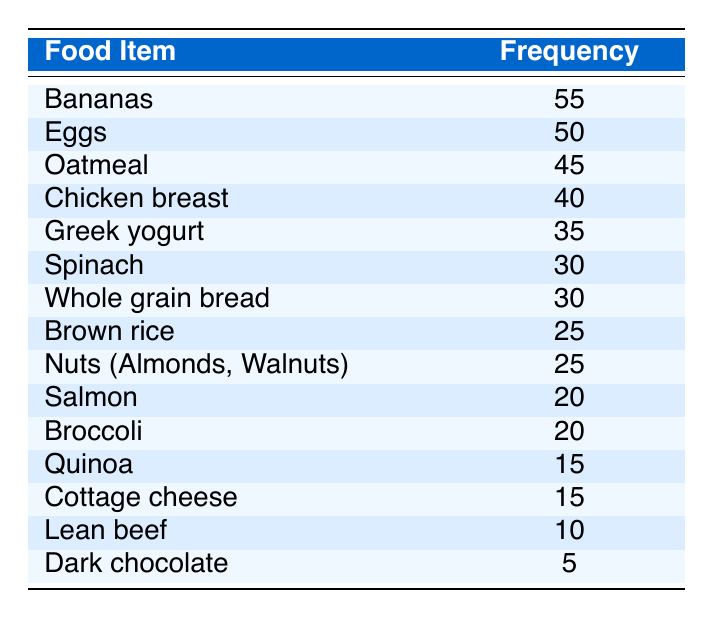What is the most frequently consumed food item among the gymnasts? The food item listed first in the table is "Bananas," with its frequency denoted as 55. This means that bananas are the most frequently consumed food item among the gymnasts.
Answer: Bananas How many food items are consumed more frequently than salmon? In the table, salmon has a frequency of 20. By checking each food item, we find that there are eight items with higher frequencies: bananas, eggs, oatmeal, chicken breast, Greek yogurt, spinach, whole grain bread, and brown rice. Therefore, eight items are consumed more frequently than salmon.
Answer: 8 What is the total frequency of the top three food items? The top three food items based on frequency are bananas (55), eggs (50), and oatmeal (45). Adding these frequencies together: 55 + 50 + 45 = 150 gives the total frequency of the top three food items.
Answer: 150 Is chicken breast consumed more than eggs? Chicken breast has a frequency of 40 and eggs have a frequency of 50. Since 40 is less than 50, chicken breast is not consumed more than eggs.
Answer: No What is the average frequency of the food items that have a frequency of 30 or more? The food items with a frequency of 30 or more are bananas (55), eggs (50), oatmeal (45), chicken breast (40), Greek yogurt (35), spinach (30), and whole grain bread (30). There are 7 items, and their total frequency is 55 + 50 + 45 + 40 + 35 + 30 + 30 = 285. The average frequency is then calculated: 285 / 7 ≈ 40.71.
Answer: 40.71 